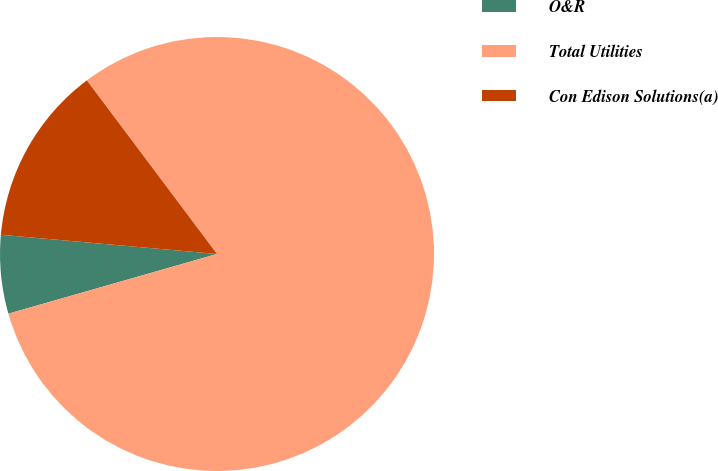Convert chart to OTSL. <chart><loc_0><loc_0><loc_500><loc_500><pie_chart><fcel>O&R<fcel>Total Utilities<fcel>Con Edison Solutions(a)<nl><fcel>5.85%<fcel>80.81%<fcel>13.35%<nl></chart> 